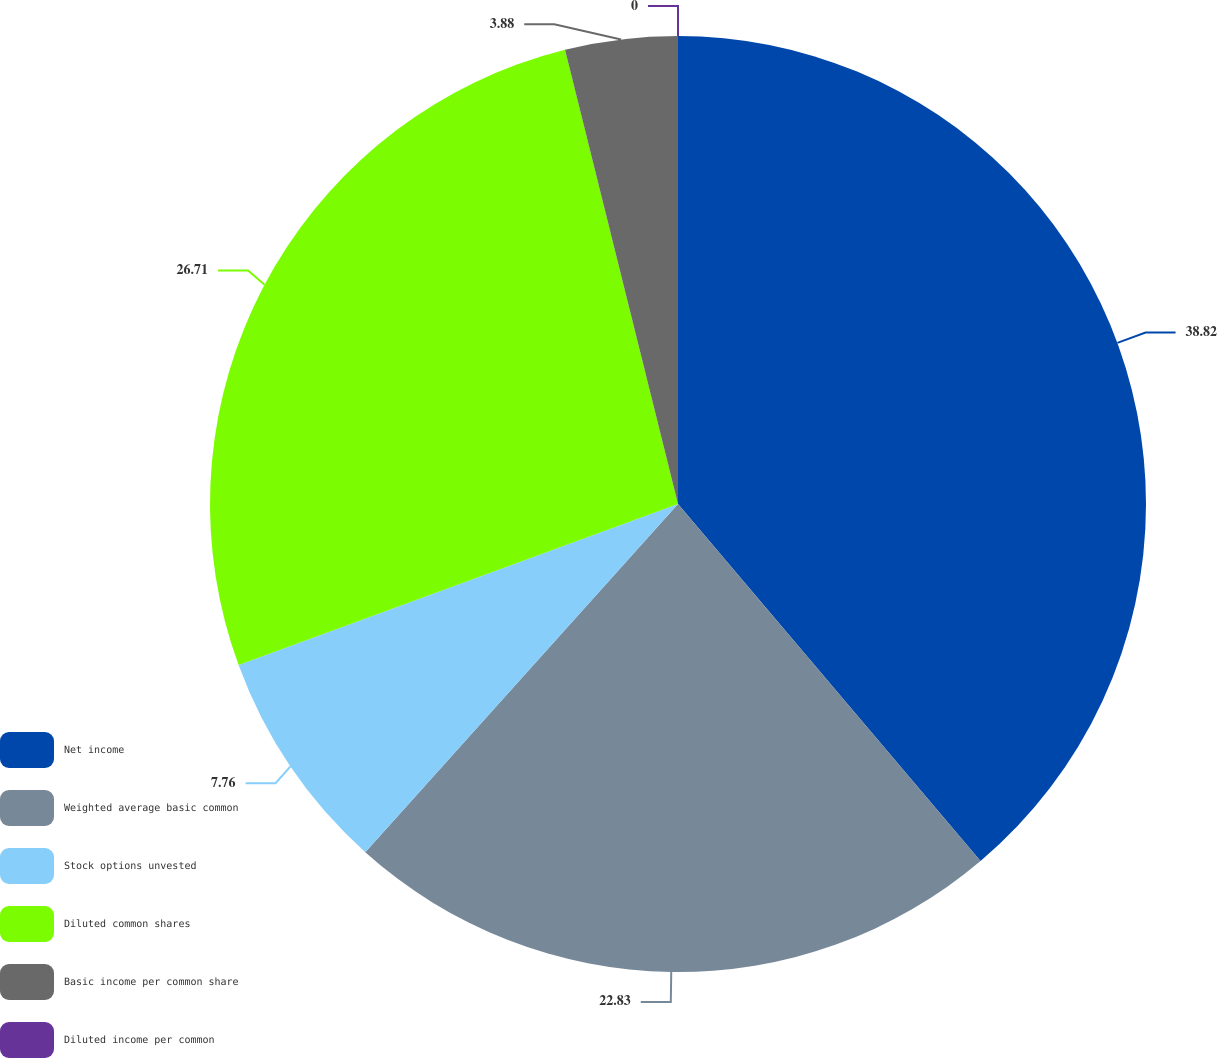Convert chart to OTSL. <chart><loc_0><loc_0><loc_500><loc_500><pie_chart><fcel>Net income<fcel>Weighted average basic common<fcel>Stock options unvested<fcel>Diluted common shares<fcel>Basic income per common share<fcel>Diluted income per common<nl><fcel>38.81%<fcel>22.83%<fcel>7.76%<fcel>26.71%<fcel>3.88%<fcel>0.0%<nl></chart> 